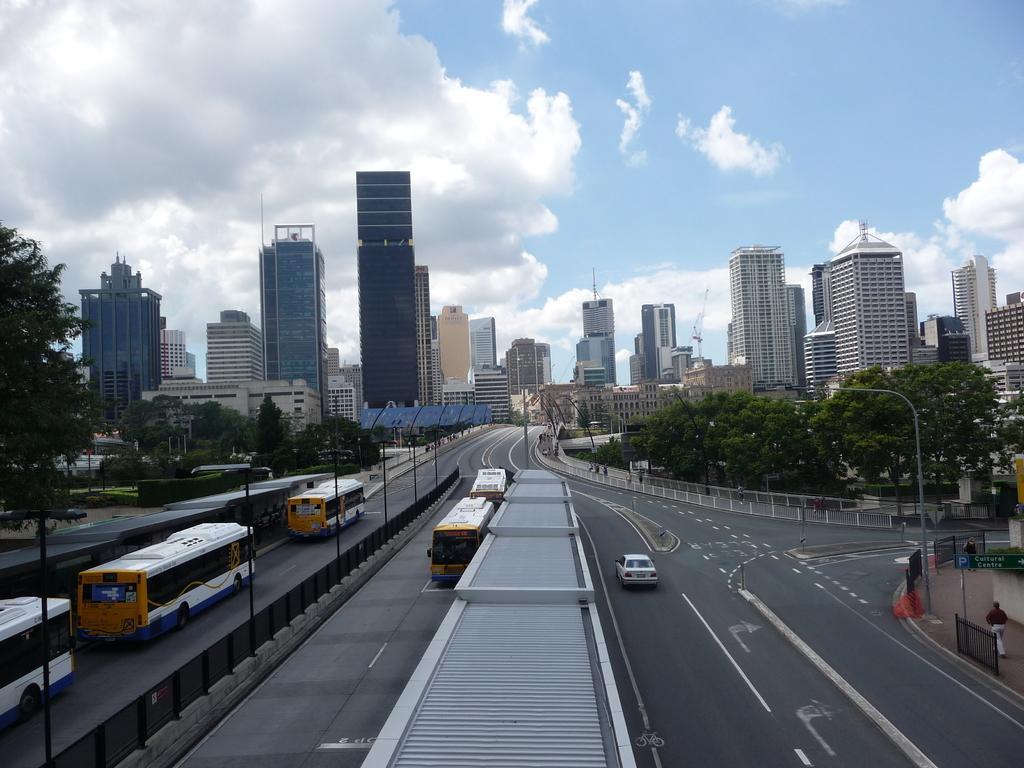Describe this image in one or two sentences. In this image, we can see vehicles on the road and in the background, there are buildings, trees, poles, lights and we can see some people, railings and some boards. At the top, there are clouds in the sky. 